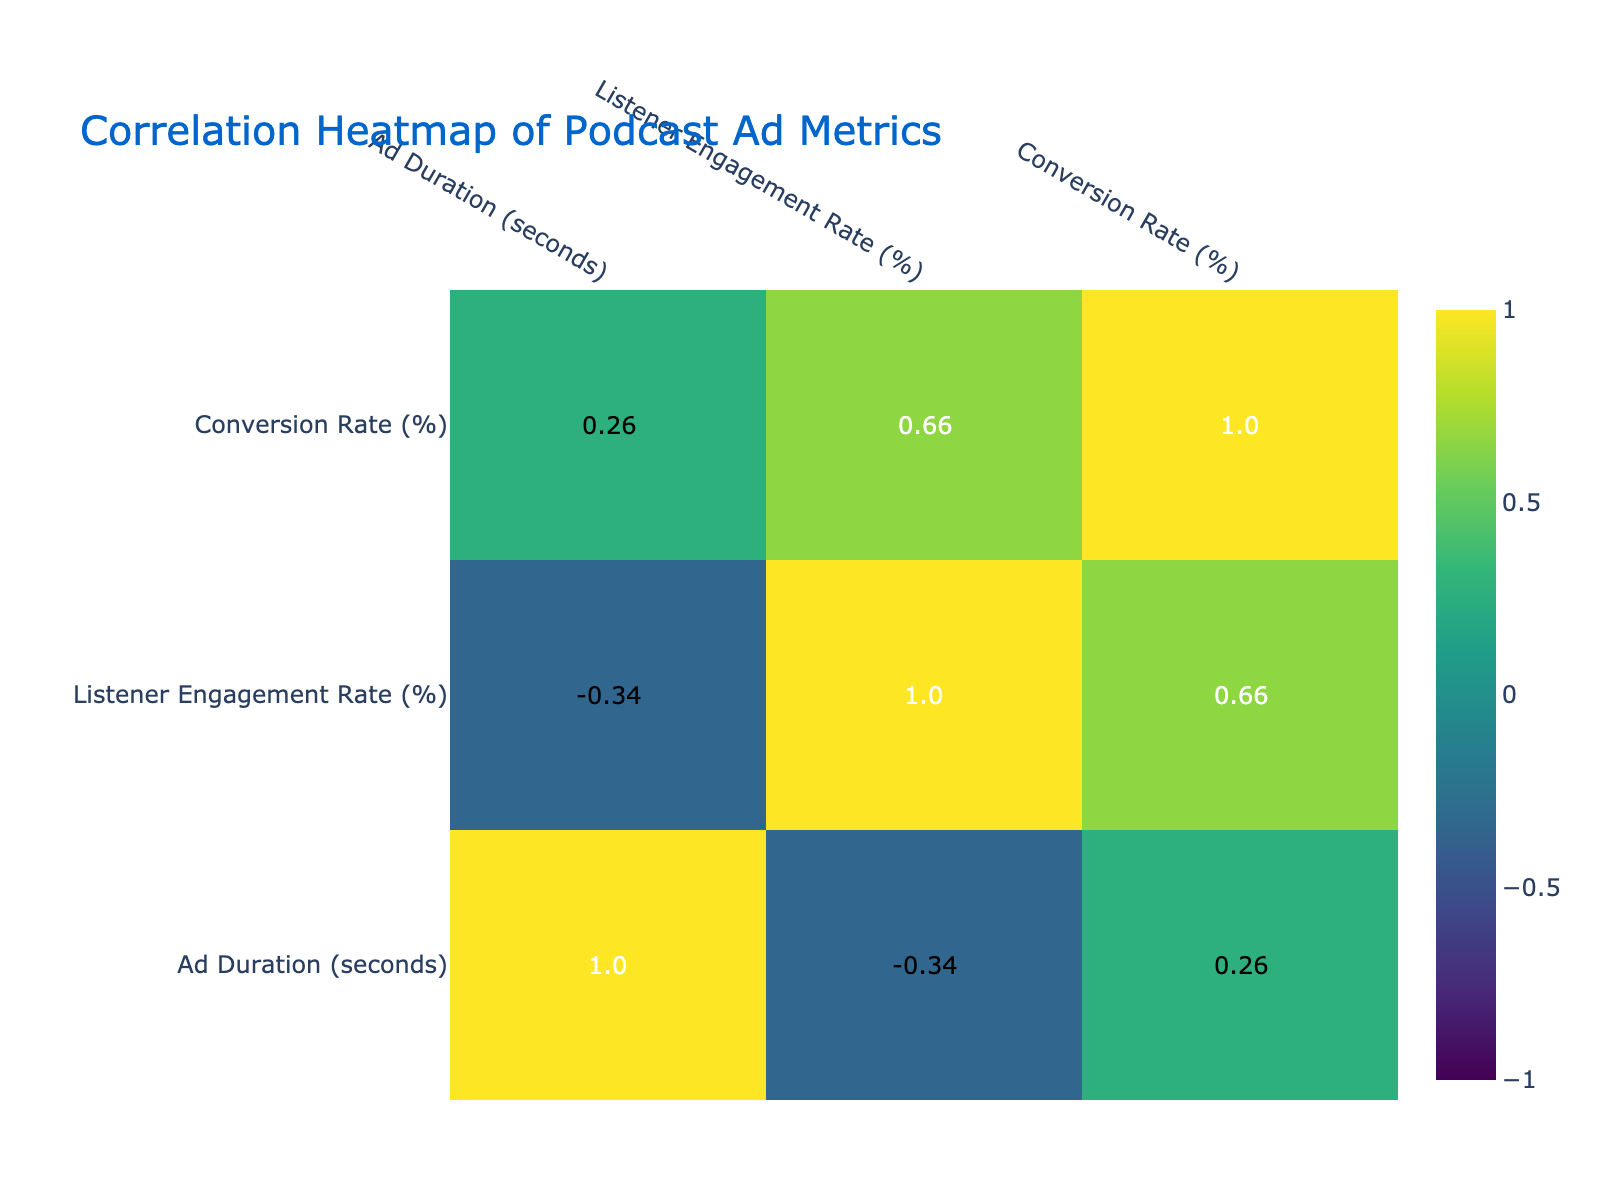What is the conversion rate for "Radiolab"? The conversion rate for "Radiolab" is provided in the table under the "Conversion Rate (%)" column. It states that the conversion rate is 8.0%.
Answer: 8.0 What is the ad duration for "Stuff You Should Know"? The ad duration for "Stuff You Should Know" can be found in the "Ad Duration (seconds)" column of the table. The duration is 60 seconds.
Answer: 60 seconds Which podcast has the highest listener engagement rate? To find the podcast with the highest listener engagement rate, I compare all the values in the "Listener Engagement Rate (%)" column. "Radiolab" has the highest engagement rate at 35.0%.
Answer: "Radiolab" What is the average conversion rate for podcasts using mid-roll ad placements? First, I identify the podcasts with mid-roll placements: "Hidden Brain" (5.2%), "Stuff You Should Know" (7.5%), and "Freakonomics Radio" (4.5%). Summing these gives 5.2 + 7.5 + 4.5 = 17.2%. Next, I divide by 3 (the number of mid-roll podcasts) which results in an average conversion rate of 5.73%.
Answer: 5.73% Is it true that "Armchair Expert" has a higher conversion rate than "Criminal"? I check the "Conversion Rate (%)" for both podcasts in the table. "Armchair Expert" has 5.9% and "Criminal" has 3.7%. Since 5.9% is greater than 3.7%, the statement is true.
Answer: Yes Which type of ad placement had the lowest listener engagement rate? I review the "Listener Engagement Rate (%)" for all ad types. The lowest engagement rate is for the "Freakonomics Radio" podcast with 20.5%.
Answer: "Mid-roll" What is the difference in listener engagement rates between "The Daily" and "Pod Save America"? I find the engagement rates for both podcasts: "The Daily" is 28.4% and "Pod Save America" is 32.8%. To find the difference, I subtract: 32.8 - 28.4 = 4.4%.
Answer: 4.4% How does the listener engagement rate compare between pre-roll and post-roll ads? I need to compare the average listener engagement rates of pre-roll and post-roll. The pre-roll podcasts are "Reply All" (30.1%), "Radiolab" (35.0%), and "Pod Save America" (32.8%). Their average is (30.1 + 35.0 + 32.8) / 3 = 32.63%. The post-roll podcasts are "The Daily" (28.4%), "Criminal" (22.0%), and "TED Radio Hour" (26.1%). Their average is (28.4 + 22.0 + 26.1) / 3 = 25.53%. Therefore, pre-roll has a higher engagement rate than post-roll by 32.63% - 25.53% = 7.1%.
Answer: Pre-roll has a higher engagement rate by 7.1% 